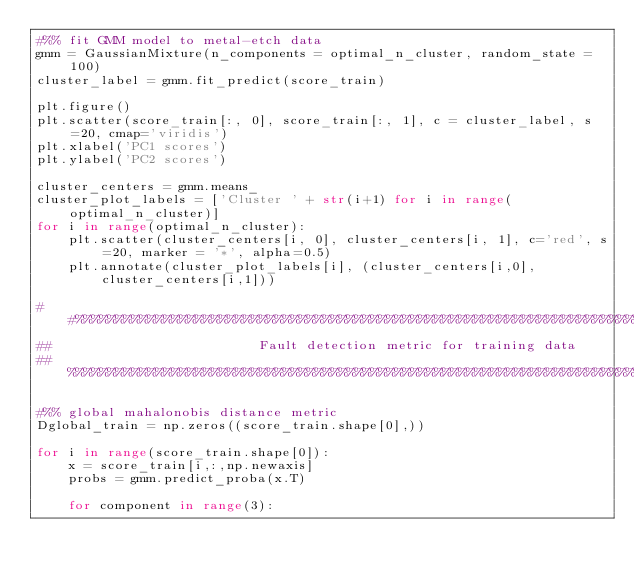<code> <loc_0><loc_0><loc_500><loc_500><_Python_>#%% fit GMM model to metal-etch data
gmm = GaussianMixture(n_components = optimal_n_cluster, random_state = 100)
cluster_label = gmm.fit_predict(score_train)

plt.figure()
plt.scatter(score_train[:, 0], score_train[:, 1], c = cluster_label, s=20, cmap='viridis')
plt.xlabel('PC1 scores')
plt.ylabel('PC2 scores')

cluster_centers = gmm.means_
cluster_plot_labels = ['Cluster ' + str(i+1) for i in range(optimal_n_cluster)]
for i in range(optimal_n_cluster):
    plt.scatter(cluster_centers[i, 0], cluster_centers[i, 1], c='red', s=20, marker = '*', alpha=0.5)
    plt.annotate(cluster_plot_labels[i], (cluster_centers[i,0], cluster_centers[i,1]))

##%%%%%%%%%%%%%%%%%%%%%%%%%%%%%%%%%%%%%%%%%%%%%%%%%%%%%%%%%%%%%%%%%%%%%%%%%%%%%
##                          Fault detection metric for training data
## %%%%%%%%%%%%%%%%%%%%%%%%%%%%%%%%%%%%%%%%%%%%%%%%%%%%%%%%%%%%%%%%%%%%%%%%%%%%

#%% global mahalonobis distance metric
Dglobal_train = np.zeros((score_train.shape[0],))

for i in range(score_train.shape[0]):
    x = score_train[i,:,np.newaxis]
    probs = gmm.predict_proba(x.T)
    
    for component in range(3):</code> 